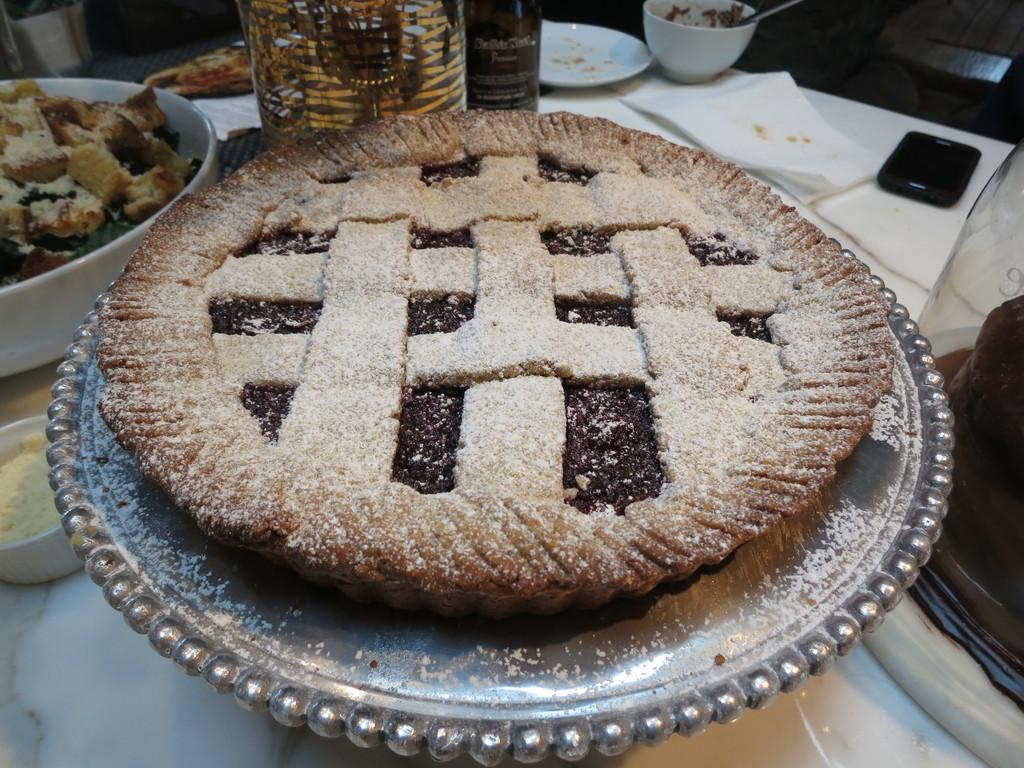What types of dishes are visible in the image? There are plates and bowls in the image. What else can be seen in the image besides dishes? There are bottles, tissue papers, and a phone in the image. Where is the phone located in the image? The phone is on a table in the image. What might be used for cleaning or wiping in the image? Tissue papers are present in the image for cleaning or wiping. Is there any food visible in the image? Yes, there is food on a plate in the image. What type of floor can be seen in the image? There is no floor visible in the image; it only shows objects on a table. 